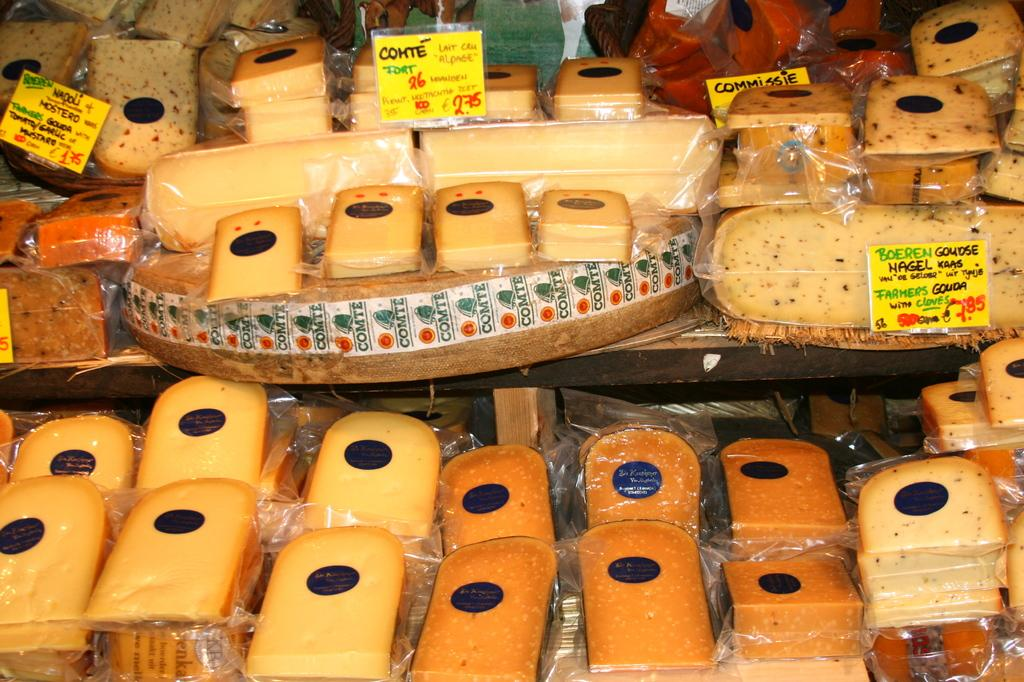What type of objects can be seen in the image? There are food items and boards in the image. What color are the food items? The food items are in brown color. What color are the boards? The boards are in yellow color. What is written on the boards? There is writing on the boards. What time does the peace sign appear in the image? There is no peace sign present in the image. 